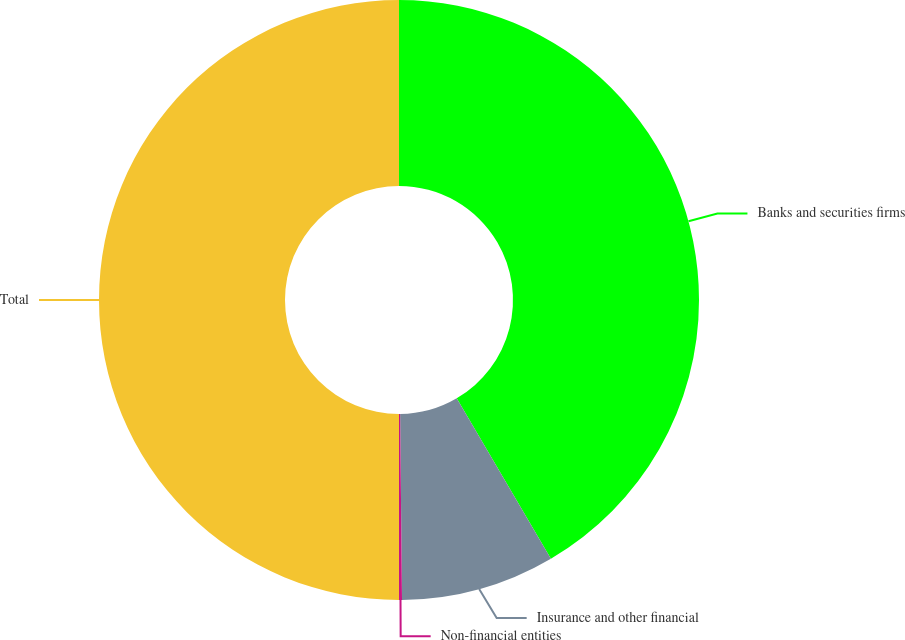Convert chart. <chart><loc_0><loc_0><loc_500><loc_500><pie_chart><fcel>Banks and securities firms<fcel>Insurance and other financial<fcel>Non-financial entities<fcel>Total<nl><fcel>41.55%<fcel>8.29%<fcel>0.16%<fcel>50.0%<nl></chart> 